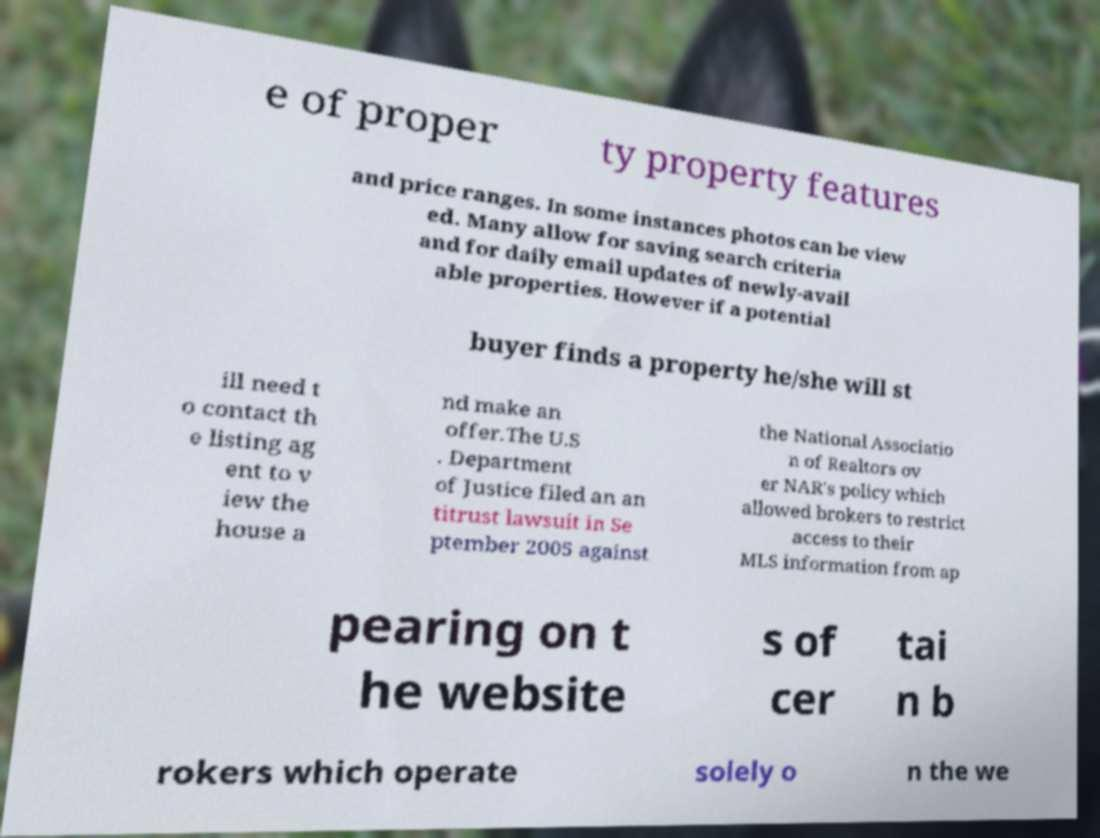Please identify and transcribe the text found in this image. e of proper ty property features and price ranges. In some instances photos can be view ed. Many allow for saving search criteria and for daily email updates of newly-avail able properties. However if a potential buyer finds a property he/she will st ill need t o contact th e listing ag ent to v iew the house a nd make an offer.The U.S . Department of Justice filed an an titrust lawsuit in Se ptember 2005 against the National Associatio n of Realtors ov er NAR's policy which allowed brokers to restrict access to their MLS information from ap pearing on t he website s of cer tai n b rokers which operate solely o n the we 